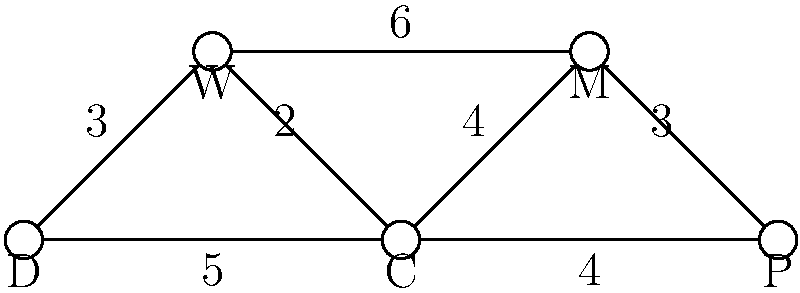In an open office layout, you need to optimize the placement of different furniture types to minimize movement between them. The node-link diagram represents the furniture arrangement, where nodes represent furniture types (D: Desk, W: Workstation, C: Conference table, M: Meeting area, P: Printer station) and edges represent paths between them. The weights on the edges indicate the average time (in seconds) it takes to move between furniture types. What is the minimum total time required to visit all furniture types exactly once, starting and ending at the Desk (D)? To solve this problem, we need to find the shortest Hamiltonian cycle that starts and ends at node D. This is known as the Traveling Salesman Problem. Here's a step-by-step approach:

1. List all possible Hamiltonian cycles starting and ending at D:
   - D-W-C-M-P-D
   - D-W-M-C-P-D
   - D-C-W-M-P-D
   - D-C-P-M-W-D
   - D-P-C-M-W-D

2. Calculate the total time for each cycle:
   - D-W-C-M-P-D: 3 + 2 + 4 + 3 + 4 = 16 seconds
   - D-W-M-C-P-D: 3 + 6 + 4 + 4 + 4 = 21 seconds
   - D-C-W-M-P-D: 5 + 2 + 4 + 3 + 4 = 18 seconds
   - D-C-P-M-W-D: 5 + 4 + 4 + 6 + 3 = 22 seconds
   - D-P-C-M-W-D: 4 + 4 + 4 + 6 + 3 = 21 seconds

3. Identify the cycle with the minimum total time:
   The cycle D-W-C-M-P-D has the shortest total time of 16 seconds.

Therefore, the minimum total time required to visit all furniture types exactly once, starting and ending at the Desk (D), is 16 seconds.
Answer: 16 seconds 